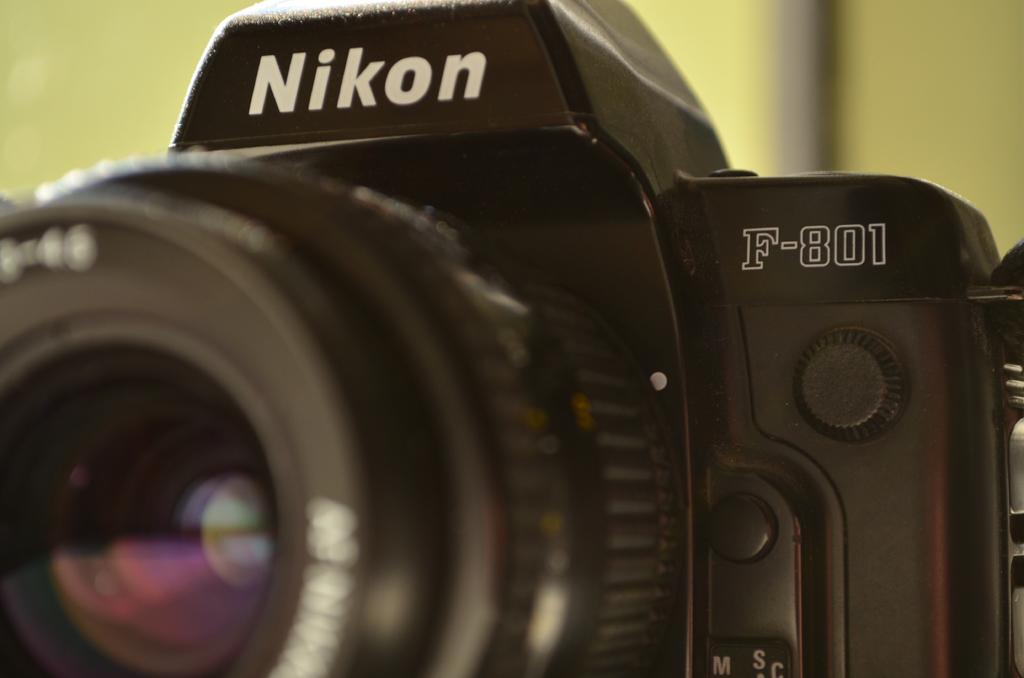What object is the main subject of the picture? There is a camera in the picture. Are there any words or letters on the camera? Yes, there is text on the camera. How would you describe the appearance of the background in the image? The background of the image appears blurry. What type of beam can be seen supporting the camera in the image? There is no beam visible in the image; the camera is the main subject. 